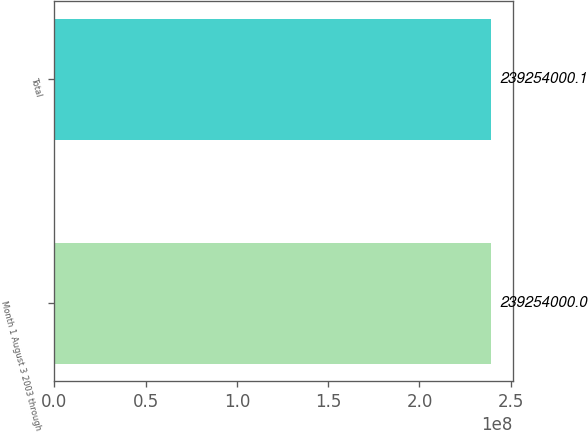Convert chart. <chart><loc_0><loc_0><loc_500><loc_500><bar_chart><fcel>Month 1 August 3 2003 through<fcel>Total<nl><fcel>2.39254e+08<fcel>2.39254e+08<nl></chart> 